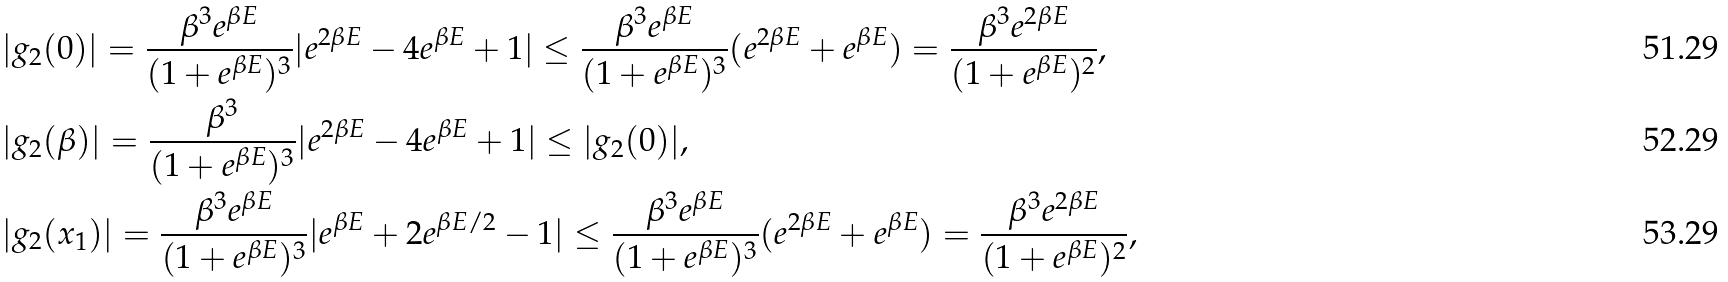<formula> <loc_0><loc_0><loc_500><loc_500>& | g _ { 2 } ( 0 ) | = \frac { \beta ^ { 3 } e ^ { \beta E } } { ( 1 + e ^ { \beta E } ) ^ { 3 } } | e ^ { 2 \beta E } - 4 e ^ { \beta E } + 1 | \leq \frac { \beta ^ { 3 } e ^ { \beta E } } { ( 1 + e ^ { \beta E } ) ^ { 3 } } ( e ^ { 2 \beta E } + e ^ { \beta E } ) = \frac { \beta ^ { 3 } e ^ { 2 \beta E } } { ( 1 + e ^ { \beta E } ) ^ { 2 } } , \\ & | g _ { 2 } ( \beta ) | = \frac { \beta ^ { 3 } } { ( 1 + e ^ { \beta E } ) ^ { 3 } } | e ^ { 2 \beta E } - 4 e ^ { \beta E } + 1 | \leq | g _ { 2 } ( 0 ) | , \\ & | g _ { 2 } ( x _ { 1 } ) | = \frac { \beta ^ { 3 } e ^ { \beta E } } { ( 1 + e ^ { \beta E } ) ^ { 3 } } | e ^ { \beta E } + 2 e ^ { \beta E / 2 } - 1 | \leq \frac { \beta ^ { 3 } e ^ { \beta E } } { ( 1 + e ^ { \beta E } ) ^ { 3 } } ( e ^ { 2 \beta E } + e ^ { \beta E } ) = \frac { \beta ^ { 3 } e ^ { 2 \beta E } } { ( 1 + e ^ { \beta E } ) ^ { 2 } } ,</formula> 